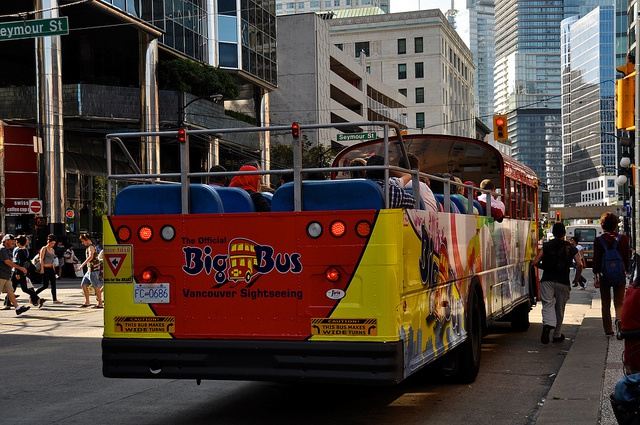Describe the objects in this image and their specific colors. I can see bus in black, maroon, gray, and olive tones, people in black, gray, maroon, and darkgray tones, people in black, gray, and maroon tones, people in black, gray, maroon, and darkgray tones, and chair in black, navy, blue, and gray tones in this image. 